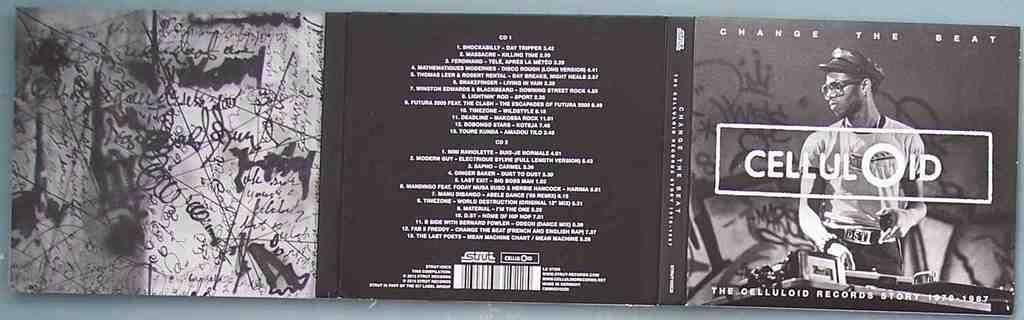<image>
Create a compact narrative representing the image presented. A CD jacket of a band name CELLULOID. 